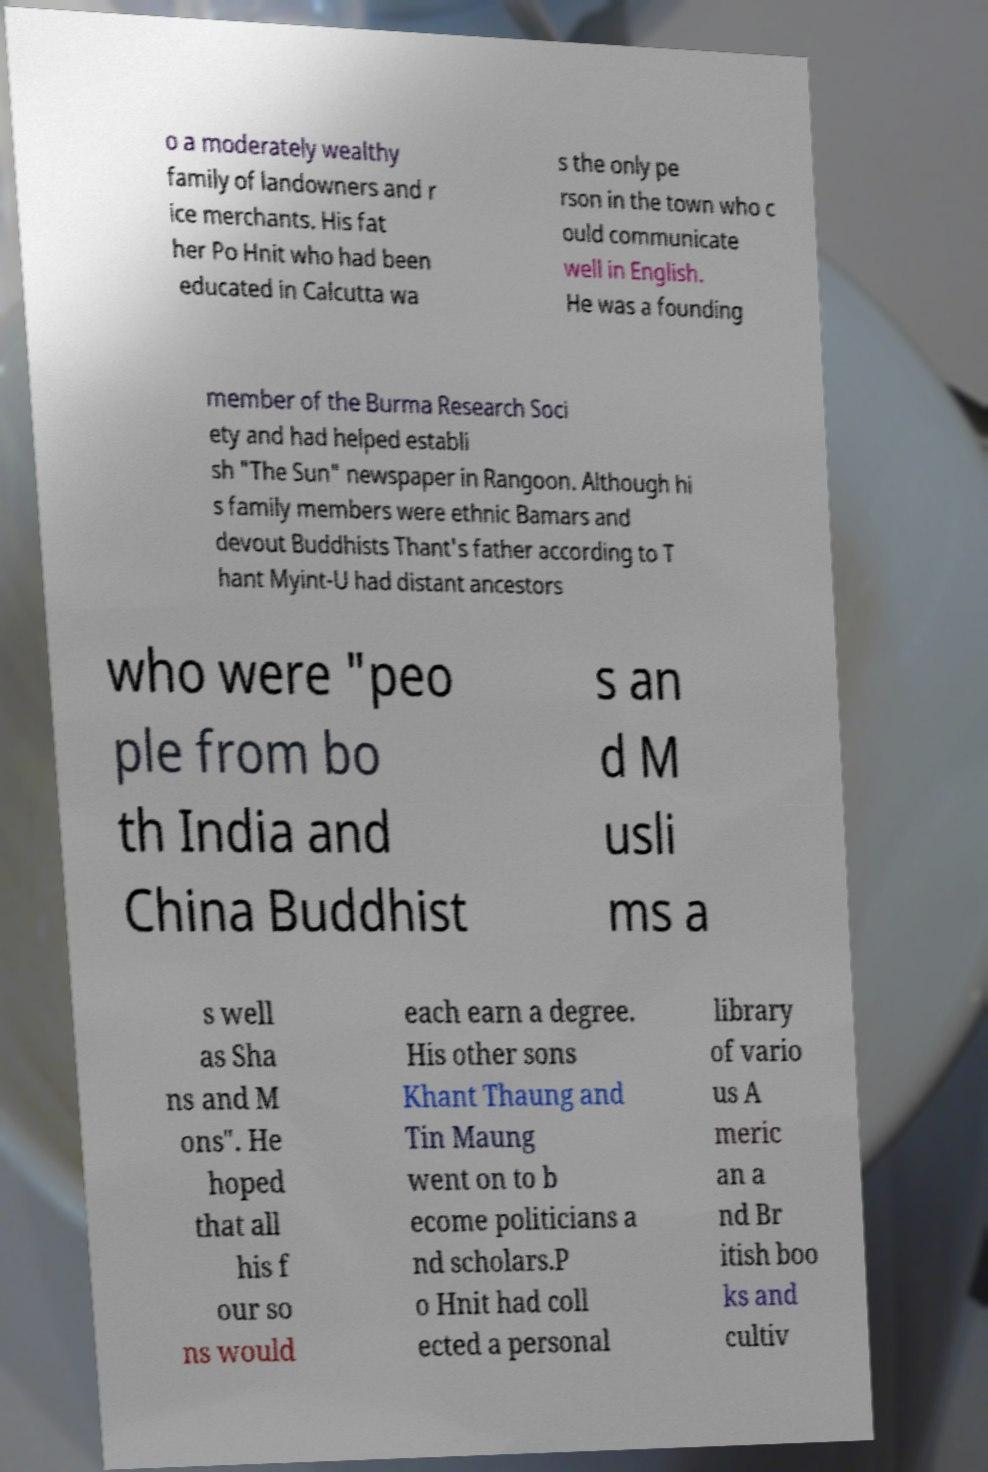I need the written content from this picture converted into text. Can you do that? o a moderately wealthy family of landowners and r ice merchants. His fat her Po Hnit who had been educated in Calcutta wa s the only pe rson in the town who c ould communicate well in English. He was a founding member of the Burma Research Soci ety and had helped establi sh "The Sun" newspaper in Rangoon. Although hi s family members were ethnic Bamars and devout Buddhists Thant's father according to T hant Myint-U had distant ancestors who were "peo ple from bo th India and China Buddhist s an d M usli ms a s well as Sha ns and M ons". He hoped that all his f our so ns would each earn a degree. His other sons Khant Thaung and Tin Maung went on to b ecome politicians a nd scholars.P o Hnit had coll ected a personal library of vario us A meric an a nd Br itish boo ks and cultiv 